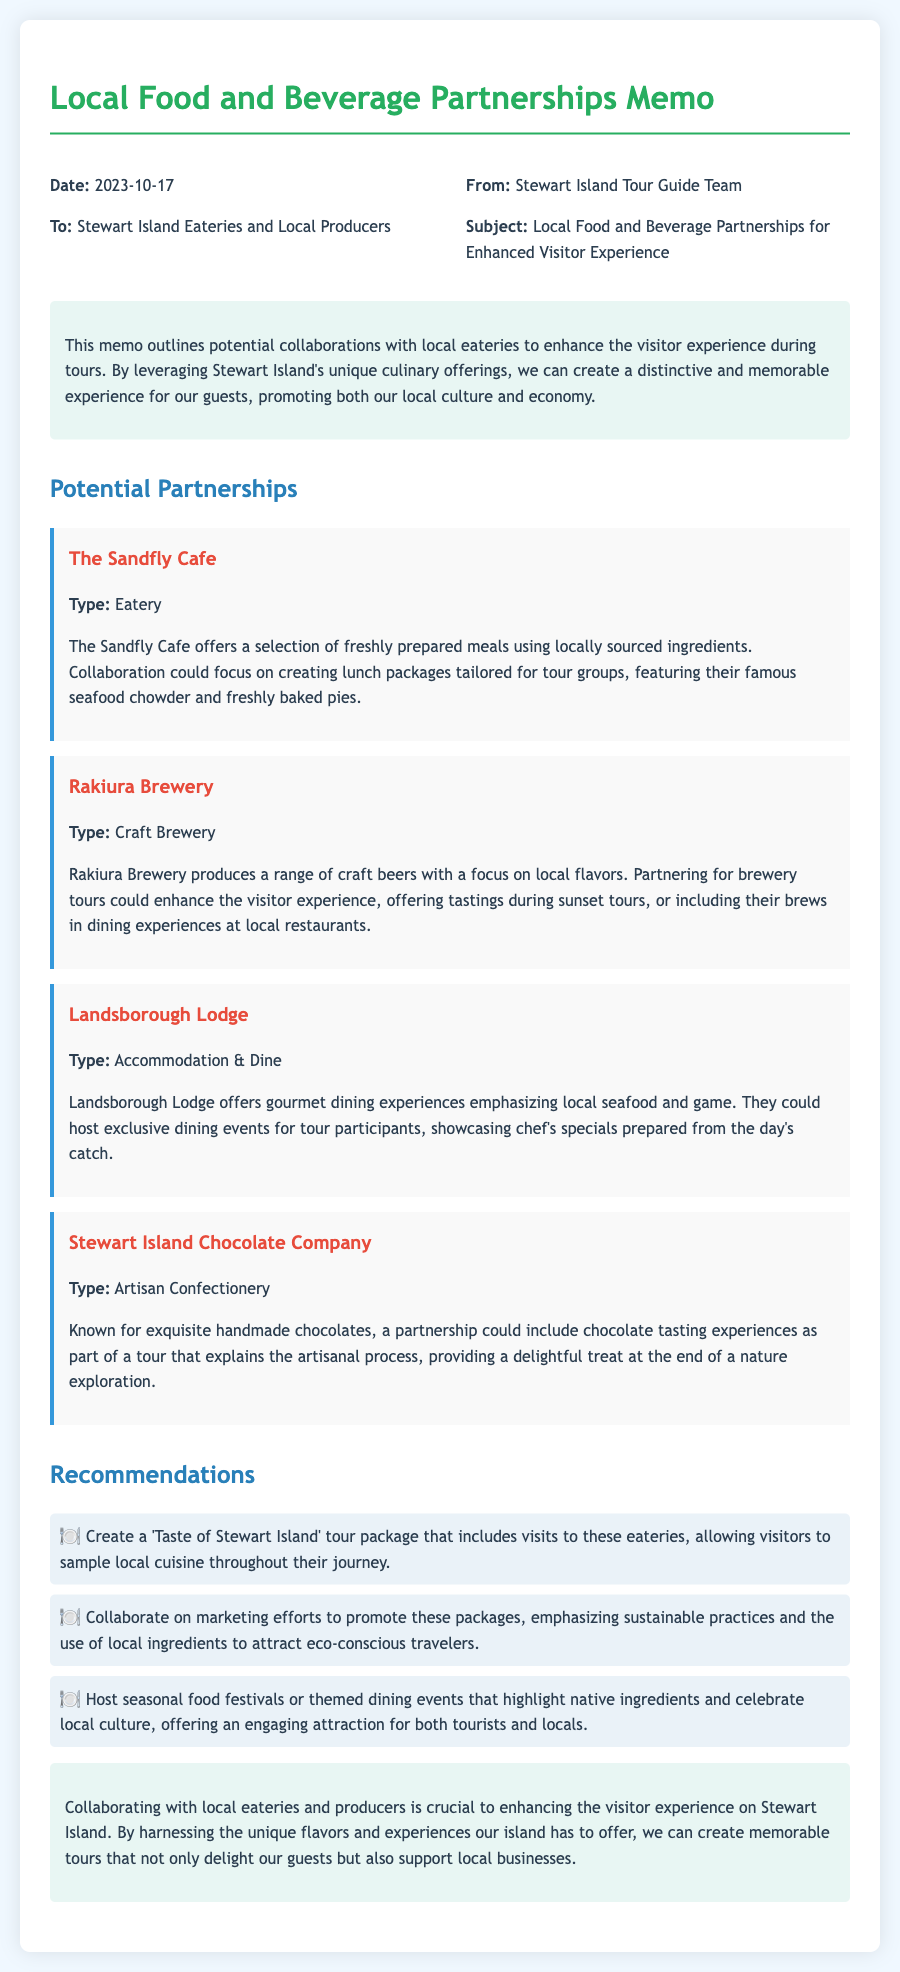What is the date of the memo? The date is explicitly mentioned in the memo header.
Answer: 2023-10-17 Who is the memo addressed to? The recipient is specified in the header of the document.
Answer: Stewart Island Eateries and Local Producers What type of establishment is Rakiura Brewery? The type of Rakiura Brewery is mentioned under the respective partnership section.
Answer: Craft Brewery What is included in the recommendations section for attracting travelers? The memo lists specific suggestions to boost tourism using local food.
Answer: Sustainable practices and the use of local ingredients Which eatery offers chocolate tasting experiences? This information is detailed under the partnership section of the memo.
Answer: Stewart Island Chocolate Company What does Landsborough Lodge emphasize in their dining experiences? The specific focus of Landsborough Lodge's dining experiences is described in the partnership overview.
Answer: Local seafood and game What is the main goal of this memo? The objective is clearly stated in the introduction.
Answer: Enhance the visitor experience during tours How many partnerships are mentioned in the memo? The memo lists each partnership, providing a clear number.
Answer: Four partnerships 